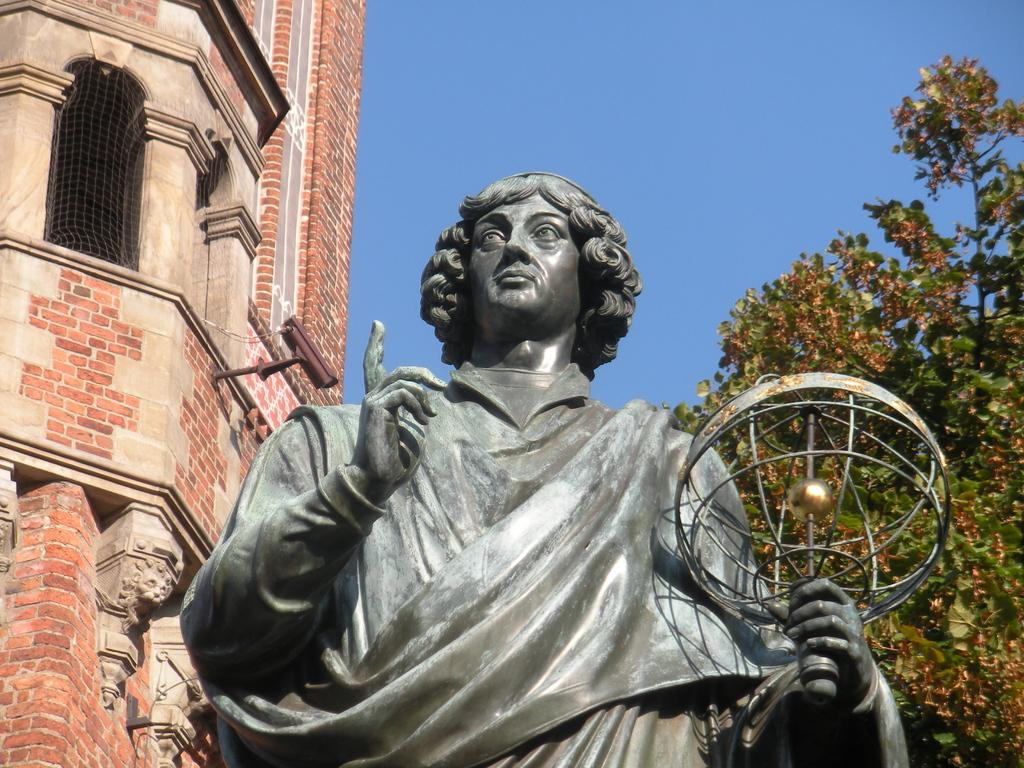What is the main subject in the image? There is a statue in the image. What can be seen behind the statue? There is a building and a tree behind the statue. What is visible in the background of the image? The sky is visible in the image. What type of knife is being used to carve the statue in the image? There is no knife present in the image, and the statue is not being carved. 